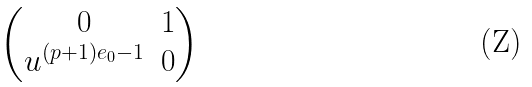<formula> <loc_0><loc_0><loc_500><loc_500>\begin{pmatrix} 0 & 1 \\ u ^ { ( p + 1 ) e _ { 0 } - 1 } & 0 \end{pmatrix}</formula> 